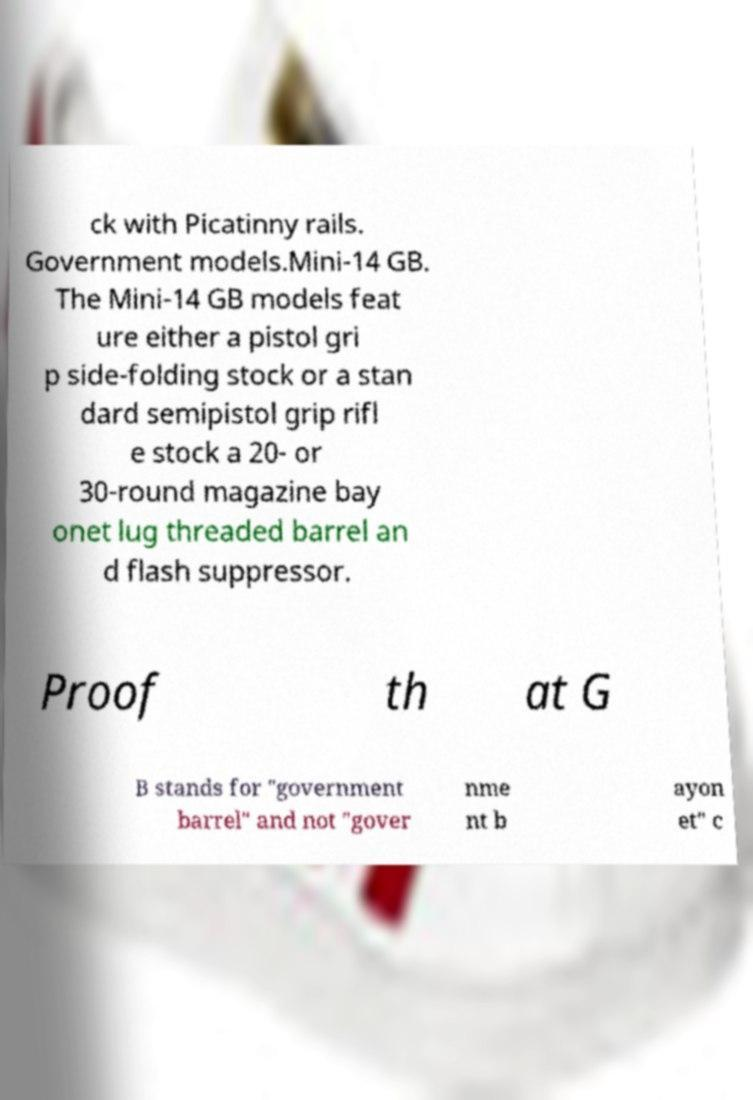Please read and relay the text visible in this image. What does it say? ck with Picatinny rails. Government models.Mini-14 GB. The Mini-14 GB models feat ure either a pistol gri p side-folding stock or a stan dard semipistol grip rifl e stock a 20- or 30-round magazine bay onet lug threaded barrel an d flash suppressor. Proof th at G B stands for "government barrel" and not "gover nme nt b ayon et" c 